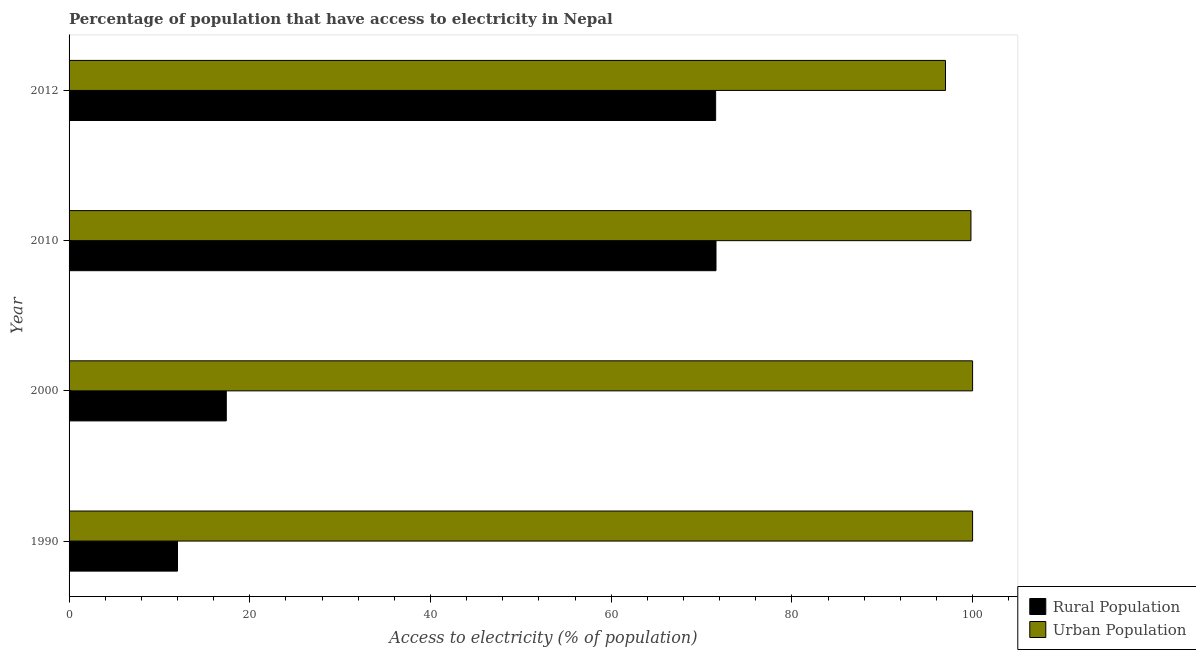How many different coloured bars are there?
Your answer should be compact. 2. How many groups of bars are there?
Give a very brief answer. 4. Are the number of bars on each tick of the Y-axis equal?
Provide a short and direct response. Yes. In how many cases, is the number of bars for a given year not equal to the number of legend labels?
Your response must be concise. 0. What is the percentage of urban population having access to electricity in 1990?
Your answer should be very brief. 100. Across all years, what is the maximum percentage of rural population having access to electricity?
Provide a short and direct response. 71.6. Across all years, what is the minimum percentage of rural population having access to electricity?
Provide a succinct answer. 12. In which year was the percentage of rural population having access to electricity maximum?
Make the answer very short. 2010. What is the total percentage of rural population having access to electricity in the graph?
Your response must be concise. 172.56. What is the difference between the percentage of rural population having access to electricity in 2000 and that in 2012?
Your response must be concise. -54.16. What is the difference between the percentage of urban population having access to electricity in 2000 and the percentage of rural population having access to electricity in 2010?
Your answer should be compact. 28.4. What is the average percentage of rural population having access to electricity per year?
Ensure brevity in your answer.  43.14. In the year 2012, what is the difference between the percentage of rural population having access to electricity and percentage of urban population having access to electricity?
Provide a succinct answer. -25.44. In how many years, is the percentage of rural population having access to electricity greater than 20 %?
Your response must be concise. 2. What is the ratio of the percentage of rural population having access to electricity in 1990 to that in 2000?
Make the answer very short. 0.69. What is the difference between the highest and the second highest percentage of rural population having access to electricity?
Your response must be concise. 0.04. What is the difference between the highest and the lowest percentage of rural population having access to electricity?
Ensure brevity in your answer.  59.6. In how many years, is the percentage of urban population having access to electricity greater than the average percentage of urban population having access to electricity taken over all years?
Provide a succinct answer. 3. What does the 1st bar from the top in 2000 represents?
Give a very brief answer. Urban Population. What does the 1st bar from the bottom in 2012 represents?
Your answer should be very brief. Rural Population. How many years are there in the graph?
Your response must be concise. 4. Are the values on the major ticks of X-axis written in scientific E-notation?
Keep it short and to the point. No. Does the graph contain grids?
Provide a succinct answer. No. Where does the legend appear in the graph?
Ensure brevity in your answer.  Bottom right. How many legend labels are there?
Your answer should be compact. 2. What is the title of the graph?
Offer a very short reply. Percentage of population that have access to electricity in Nepal. Does "GDP at market prices" appear as one of the legend labels in the graph?
Offer a very short reply. No. What is the label or title of the X-axis?
Your response must be concise. Access to electricity (% of population). What is the Access to electricity (% of population) in Rural Population in 1990?
Your answer should be compact. 12. What is the Access to electricity (% of population) of Rural Population in 2010?
Offer a terse response. 71.6. What is the Access to electricity (% of population) of Urban Population in 2010?
Ensure brevity in your answer.  99.82. What is the Access to electricity (% of population) of Rural Population in 2012?
Offer a terse response. 71.56. What is the Access to electricity (% of population) of Urban Population in 2012?
Your answer should be very brief. 97. Across all years, what is the maximum Access to electricity (% of population) in Rural Population?
Your answer should be compact. 71.6. Across all years, what is the maximum Access to electricity (% of population) in Urban Population?
Give a very brief answer. 100. Across all years, what is the minimum Access to electricity (% of population) of Rural Population?
Provide a short and direct response. 12. Across all years, what is the minimum Access to electricity (% of population) in Urban Population?
Provide a short and direct response. 97. What is the total Access to electricity (% of population) in Rural Population in the graph?
Provide a succinct answer. 172.56. What is the total Access to electricity (% of population) in Urban Population in the graph?
Provide a succinct answer. 396.82. What is the difference between the Access to electricity (% of population) of Rural Population in 1990 and that in 2000?
Your response must be concise. -5.4. What is the difference between the Access to electricity (% of population) in Rural Population in 1990 and that in 2010?
Provide a short and direct response. -59.6. What is the difference between the Access to electricity (% of population) of Urban Population in 1990 and that in 2010?
Ensure brevity in your answer.  0.18. What is the difference between the Access to electricity (% of population) of Rural Population in 1990 and that in 2012?
Give a very brief answer. -59.56. What is the difference between the Access to electricity (% of population) of Urban Population in 1990 and that in 2012?
Ensure brevity in your answer.  3. What is the difference between the Access to electricity (% of population) of Rural Population in 2000 and that in 2010?
Keep it short and to the point. -54.2. What is the difference between the Access to electricity (% of population) of Urban Population in 2000 and that in 2010?
Your answer should be very brief. 0.18. What is the difference between the Access to electricity (% of population) in Rural Population in 2000 and that in 2012?
Make the answer very short. -54.16. What is the difference between the Access to electricity (% of population) in Urban Population in 2010 and that in 2012?
Provide a succinct answer. 2.82. What is the difference between the Access to electricity (% of population) of Rural Population in 1990 and the Access to electricity (% of population) of Urban Population in 2000?
Your response must be concise. -88. What is the difference between the Access to electricity (% of population) in Rural Population in 1990 and the Access to electricity (% of population) in Urban Population in 2010?
Your answer should be compact. -87.82. What is the difference between the Access to electricity (% of population) in Rural Population in 1990 and the Access to electricity (% of population) in Urban Population in 2012?
Ensure brevity in your answer.  -85. What is the difference between the Access to electricity (% of population) of Rural Population in 2000 and the Access to electricity (% of population) of Urban Population in 2010?
Ensure brevity in your answer.  -82.42. What is the difference between the Access to electricity (% of population) of Rural Population in 2000 and the Access to electricity (% of population) of Urban Population in 2012?
Give a very brief answer. -79.6. What is the difference between the Access to electricity (% of population) in Rural Population in 2010 and the Access to electricity (% of population) in Urban Population in 2012?
Give a very brief answer. -25.4. What is the average Access to electricity (% of population) of Rural Population per year?
Your response must be concise. 43.14. What is the average Access to electricity (% of population) in Urban Population per year?
Ensure brevity in your answer.  99.2. In the year 1990, what is the difference between the Access to electricity (% of population) in Rural Population and Access to electricity (% of population) in Urban Population?
Make the answer very short. -88. In the year 2000, what is the difference between the Access to electricity (% of population) of Rural Population and Access to electricity (% of population) of Urban Population?
Your answer should be compact. -82.6. In the year 2010, what is the difference between the Access to electricity (% of population) of Rural Population and Access to electricity (% of population) of Urban Population?
Your response must be concise. -28.22. In the year 2012, what is the difference between the Access to electricity (% of population) in Rural Population and Access to electricity (% of population) in Urban Population?
Offer a terse response. -25.44. What is the ratio of the Access to electricity (% of population) in Rural Population in 1990 to that in 2000?
Keep it short and to the point. 0.69. What is the ratio of the Access to electricity (% of population) in Urban Population in 1990 to that in 2000?
Give a very brief answer. 1. What is the ratio of the Access to electricity (% of population) in Rural Population in 1990 to that in 2010?
Your response must be concise. 0.17. What is the ratio of the Access to electricity (% of population) in Urban Population in 1990 to that in 2010?
Offer a very short reply. 1. What is the ratio of the Access to electricity (% of population) in Rural Population in 1990 to that in 2012?
Your response must be concise. 0.17. What is the ratio of the Access to electricity (% of population) of Urban Population in 1990 to that in 2012?
Provide a succinct answer. 1.03. What is the ratio of the Access to electricity (% of population) in Rural Population in 2000 to that in 2010?
Keep it short and to the point. 0.24. What is the ratio of the Access to electricity (% of population) of Urban Population in 2000 to that in 2010?
Offer a terse response. 1. What is the ratio of the Access to electricity (% of population) of Rural Population in 2000 to that in 2012?
Offer a very short reply. 0.24. What is the ratio of the Access to electricity (% of population) of Urban Population in 2000 to that in 2012?
Your answer should be compact. 1.03. What is the ratio of the Access to electricity (% of population) of Rural Population in 2010 to that in 2012?
Keep it short and to the point. 1. What is the ratio of the Access to electricity (% of population) of Urban Population in 2010 to that in 2012?
Offer a terse response. 1.03. What is the difference between the highest and the second highest Access to electricity (% of population) of Rural Population?
Provide a short and direct response. 0.04. What is the difference between the highest and the second highest Access to electricity (% of population) in Urban Population?
Provide a short and direct response. 0. What is the difference between the highest and the lowest Access to electricity (% of population) of Rural Population?
Offer a terse response. 59.6. What is the difference between the highest and the lowest Access to electricity (% of population) of Urban Population?
Ensure brevity in your answer.  3. 